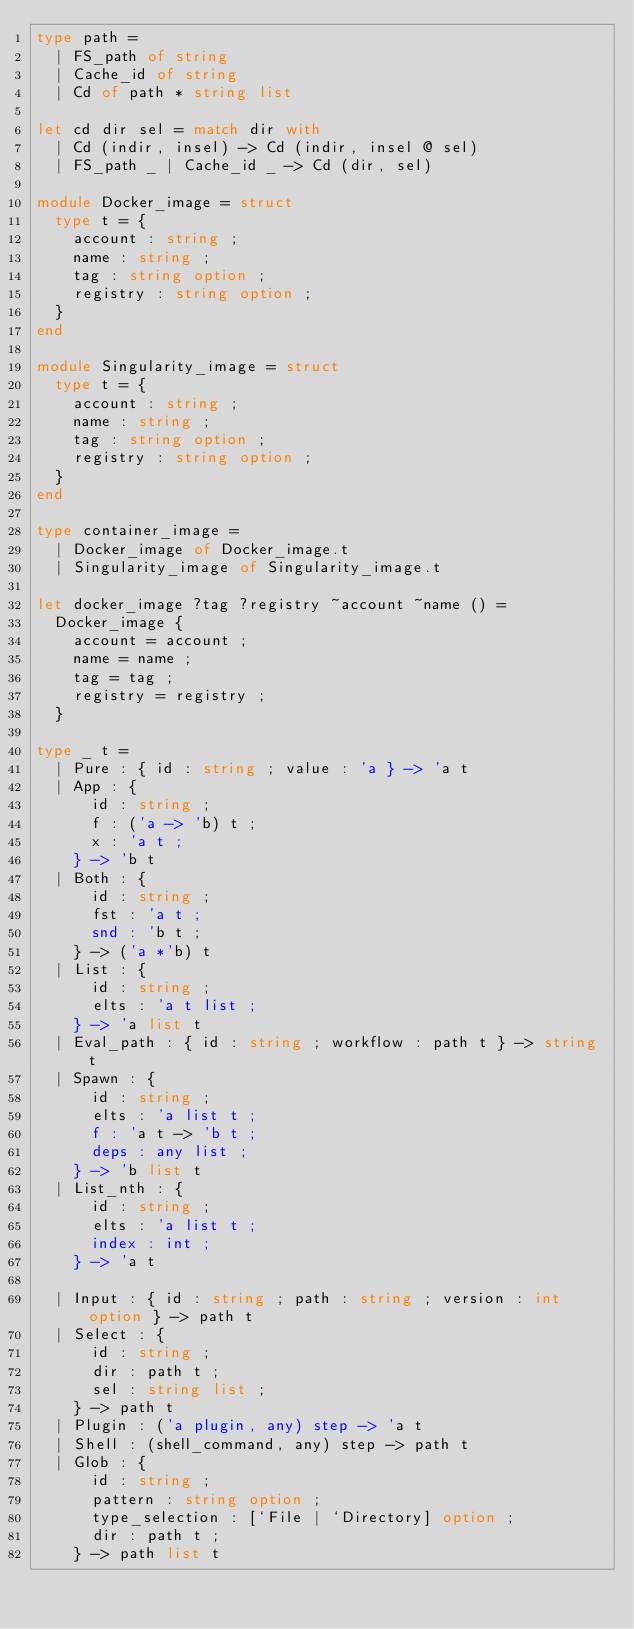<code> <loc_0><loc_0><loc_500><loc_500><_OCaml_>type path =
  | FS_path of string
  | Cache_id of string
  | Cd of path * string list

let cd dir sel = match dir with
  | Cd (indir, insel) -> Cd (indir, insel @ sel)
  | FS_path _ | Cache_id _ -> Cd (dir, sel)

module Docker_image = struct
  type t = {
    account : string ;
    name : string ;
    tag : string option ;
    registry : string option ;
  }
end

module Singularity_image = struct
  type t = {
    account : string ;
    name : string ;
    tag : string option ;
    registry : string option ;
  }
end

type container_image =
  | Docker_image of Docker_image.t
  | Singularity_image of Singularity_image.t

let docker_image ?tag ?registry ~account ~name () =
  Docker_image {
    account = account ;
    name = name ;
    tag = tag ;
    registry = registry ;
  }

type _ t =
  | Pure : { id : string ; value : 'a } -> 'a t
  | App : {
      id : string ;
      f : ('a -> 'b) t ;
      x : 'a t ;
    } -> 'b t
  | Both : {
      id : string ;
      fst : 'a t ;
      snd : 'b t ;
    } -> ('a *'b) t
  | List : {
      id : string ;
      elts : 'a t list ;
    } -> 'a list t
  | Eval_path : { id : string ; workflow : path t } -> string t
  | Spawn : {
      id : string ;
      elts : 'a list t ;
      f : 'a t -> 'b t ;
      deps : any list ;
    } -> 'b list t
  | List_nth : {
      id : string ;
      elts : 'a list t ;
      index : int ;
    } -> 'a t

  | Input : { id : string ; path : string ; version : int option } -> path t
  | Select : {
      id : string ;
      dir : path t ;
      sel : string list ;
    } -> path t
  | Plugin : ('a plugin, any) step -> 'a t
  | Shell : (shell_command, any) step -> path t
  | Glob : {
      id : string ;
      pattern : string option ;
      type_selection : [`File | `Directory] option ;
      dir : path t ;
    } -> path list t</code> 